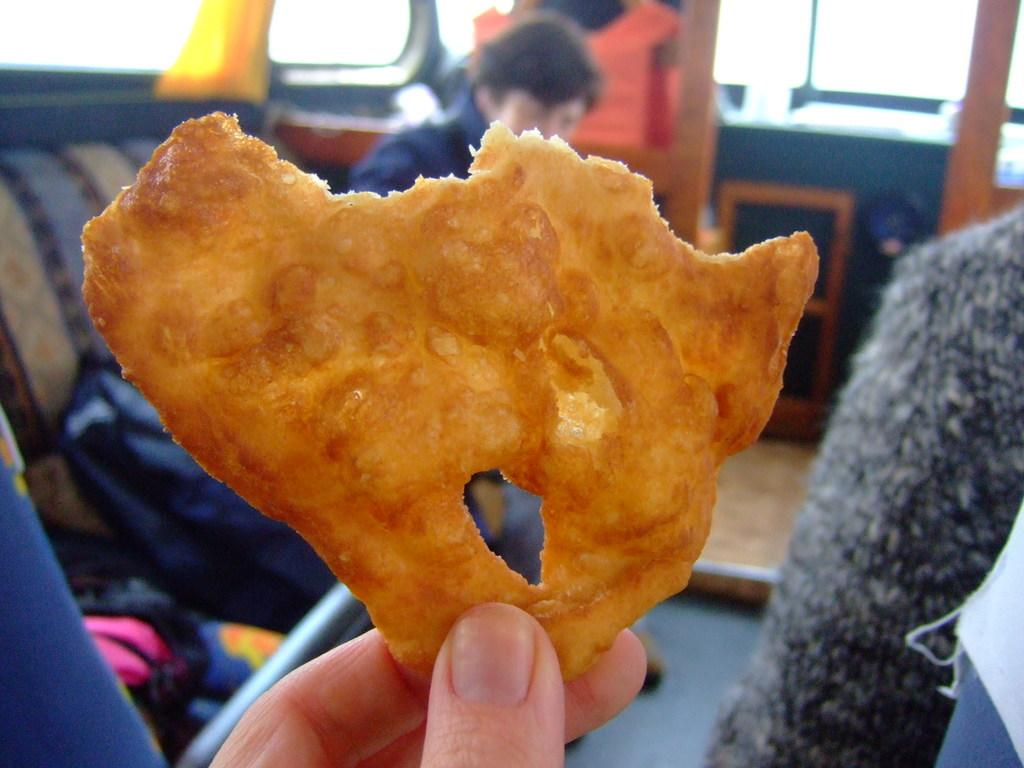What is the person in the image doing with their fingers? The person is holding a food item with their fingers in the image. Can you describe the other person in the image? There is another person beside the first person in the image. How would you describe the quality of the image? The image is slightly blurred. What type of scent can be detected from the food item in the image? There is no information about the scent of the food item in the image, as it is a visual medium. 